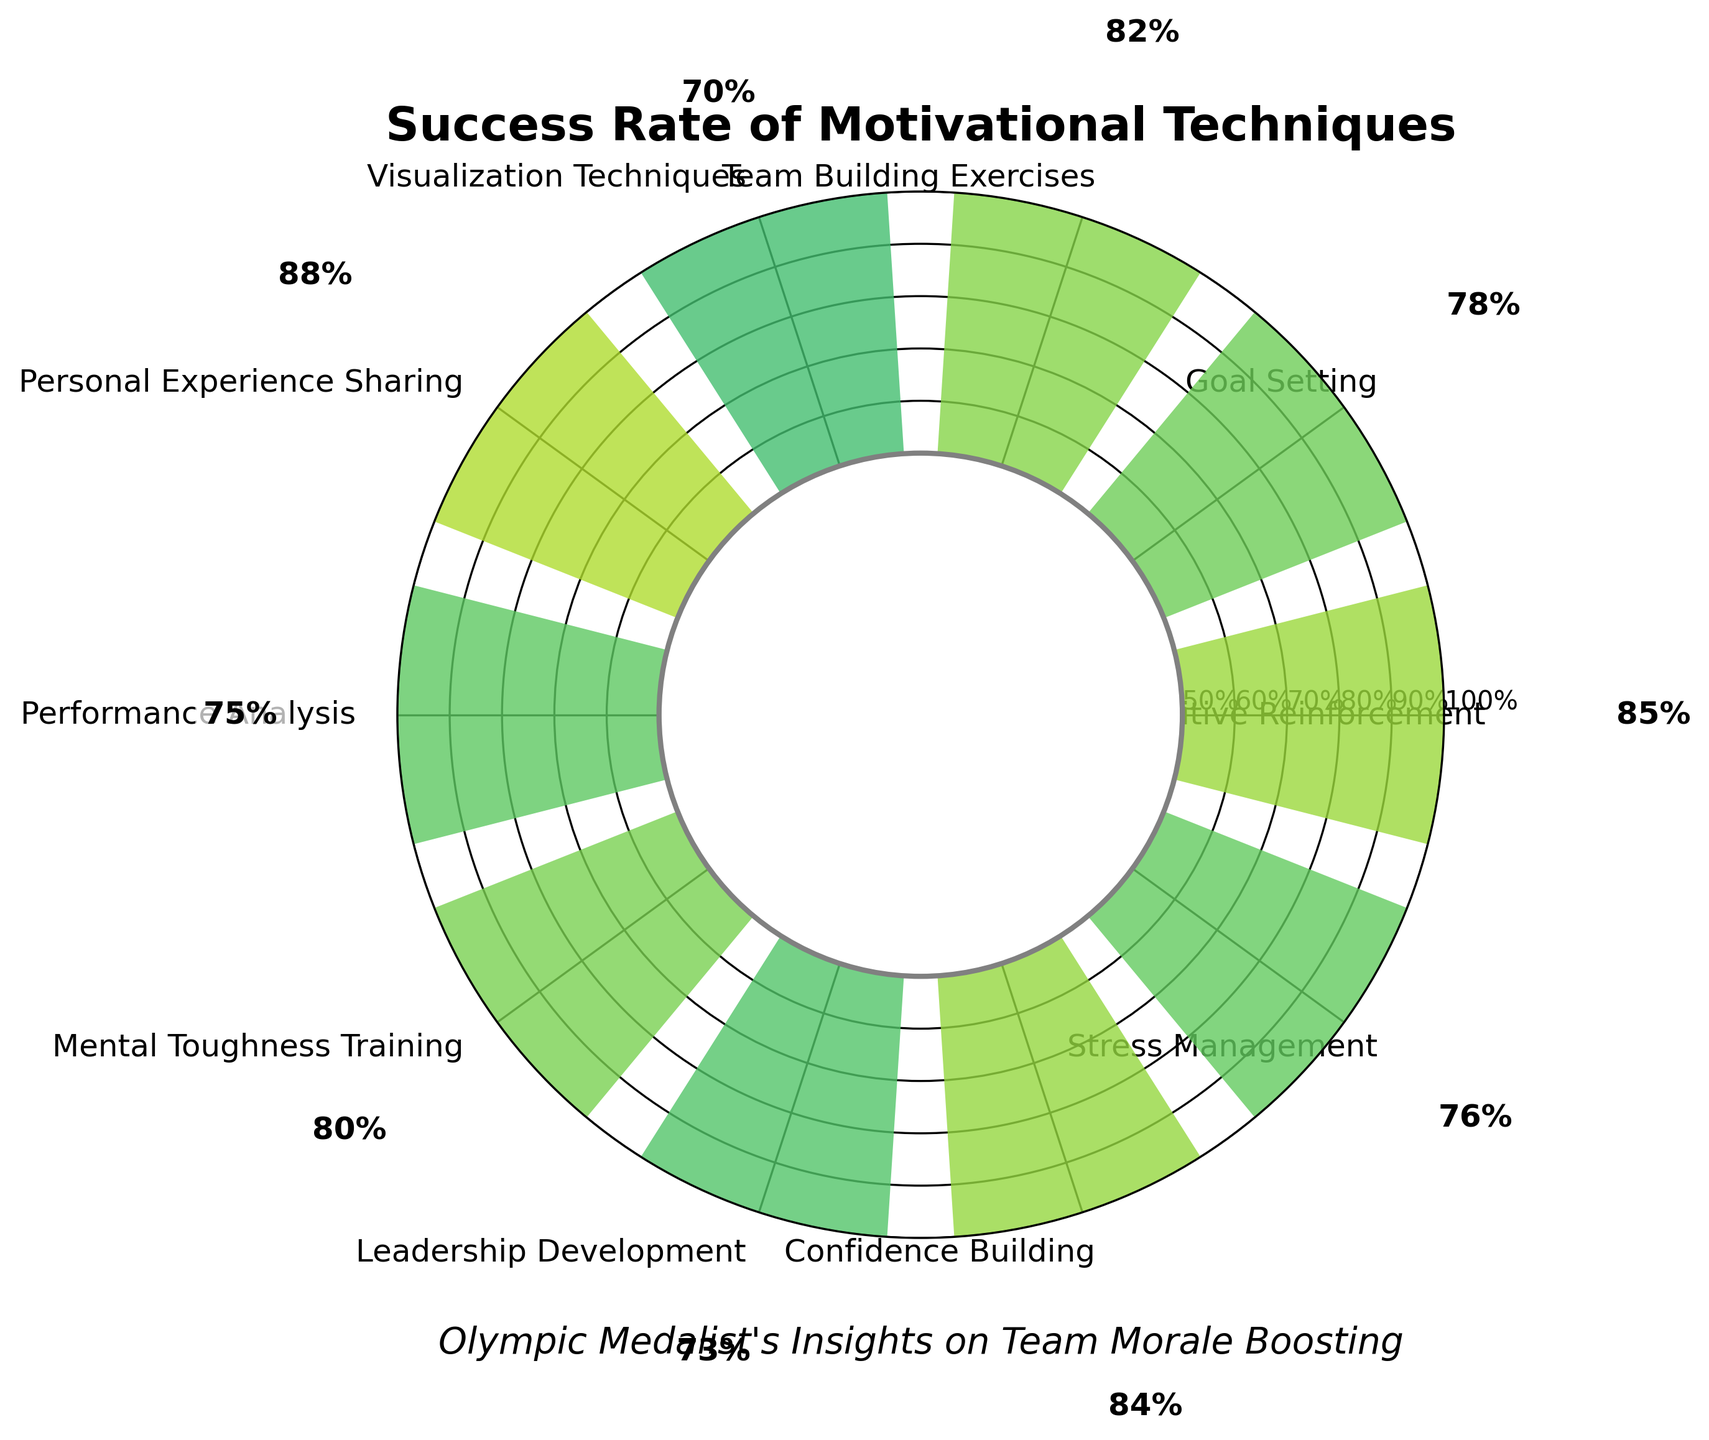What is the title of the chart? The title of the chart is located at the top and reads “Success Rate of Motivational Techniques”
Answer: Success Rate of Motivational Techniques What technique has the highest success rate? The motivational technique with the highest success rate is identified by looking at the bars and their corresponding labels. The highest rate is 88%, belonging to Personal Experience Sharing.
Answer: Personal Experience Sharing How many motivational techniques are represented in the chart? To find the number of techniques, count the number of distinct bars or labels around the chart. There are 10 techniques displayed.
Answer: 10 What is the success rate of Goal Setting? The success rate of Goal Setting can be read from the bar labeled “Goal Setting.” The value next to the bar is 78%.
Answer: 78% Which technique has a lower success rate: Stress Management or Leadership Development? By comparing the bars and their success rates, Stress Management has a success rate of 76%, while Leadership Development has a success rate of 73%. Thus, Leadership Development has a lower success rate.
Answer: Leadership Development What is the average success rate of all the techniques? To find the average success rate, sum all the success rates and divide by the number of techniques. (85 + 78 + 82 + 70 + 88 + 75 + 80 + 73 + 84 + 76) / 10 = 79.1
Answer: 79.1 Which technique falls closest to a success rate of 80%? By examining the bar heights near 80%, Mental Toughness Training has a success rate of exactly 80%.
Answer: Mental Toughness Training How does Positive Reinforcement compare to Visualization Techniques in terms of success rate? Compare the success rates of the two techniques: Positive Reinforcement has 85% and Visualization Techniques has 70%, showing Positive Reinforcement has a higher rate.
Answer: Positive Reinforcement Which technique has a success rate between 75% and 80%? From the figure, Goal Setting (78%), Performance Analysis (75%), and Stress Management (76%) fall in the range between 75% and 80%.
Answer: Goal Setting, Performance Analysis, Stress Management What is the difference in success rate between Confidence Building and Mental Toughness Training? The success rate of Confidence Building is 84% and for Mental Toughness Training it is 80%. The difference is 84% - 80% = 4%.
Answer: 4 